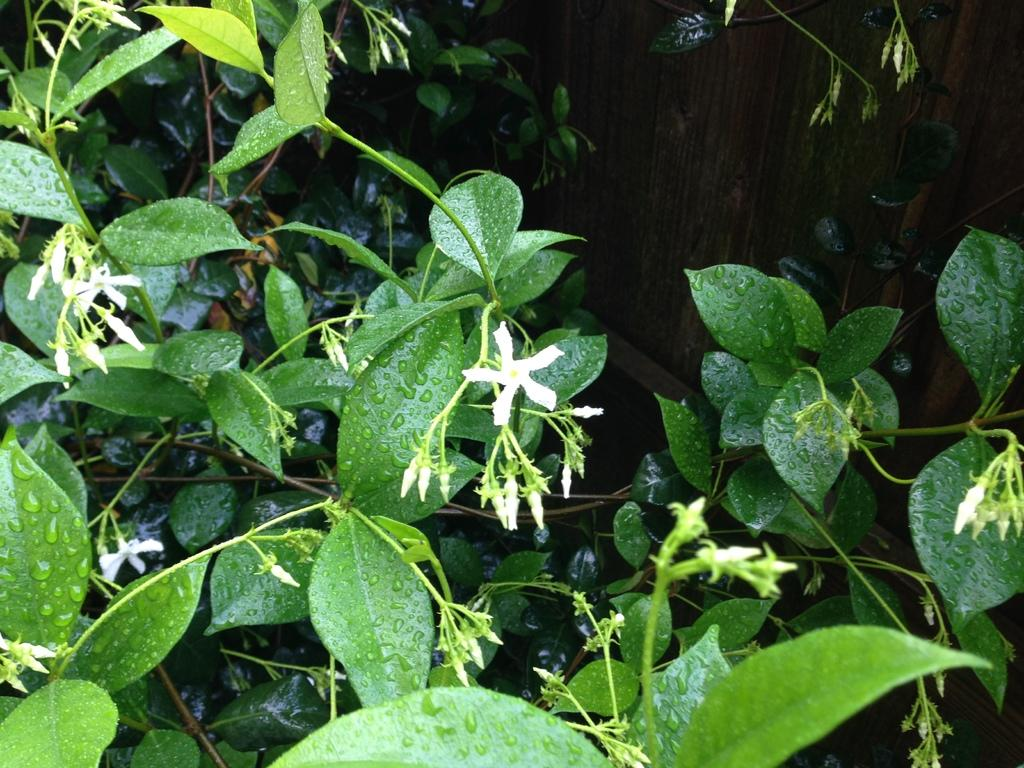What type of flora can be seen in the image? There are flowers in the image. What color are the flowers? The flowers are white. What can be seen in the background of the image? There are plants in the background of the image. What color are the plants? The plants are green. What type of laughter can be heard coming from the flowers in the image? There is no laughter present in the image, as flowers do not have the ability to laugh. 